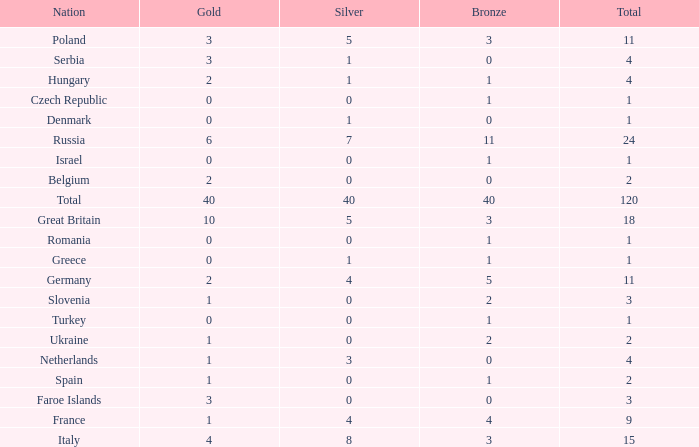What Nation has a Gold entry that is greater than 0, a Total that is greater than 2, a Silver entry that is larger than 1, and 0 Bronze? Netherlands. Would you be able to parse every entry in this table? {'header': ['Nation', 'Gold', 'Silver', 'Bronze', 'Total'], 'rows': [['Poland', '3', '5', '3', '11'], ['Serbia', '3', '1', '0', '4'], ['Hungary', '2', '1', '1', '4'], ['Czech Republic', '0', '0', '1', '1'], ['Denmark', '0', '1', '0', '1'], ['Russia', '6', '7', '11', '24'], ['Israel', '0', '0', '1', '1'], ['Belgium', '2', '0', '0', '2'], ['Total', '40', '40', '40', '120'], ['Great Britain', '10', '5', '3', '18'], ['Romania', '0', '0', '1', '1'], ['Greece', '0', '1', '1', '1'], ['Germany', '2', '4', '5', '11'], ['Slovenia', '1', '0', '2', '3'], ['Turkey', '0', '0', '1', '1'], ['Ukraine', '1', '0', '2', '2'], ['Netherlands', '1', '3', '0', '4'], ['Spain', '1', '0', '1', '2'], ['Faroe Islands', '3', '0', '0', '3'], ['France', '1', '4', '4', '9'], ['Italy', '4', '8', '3', '15']]} 